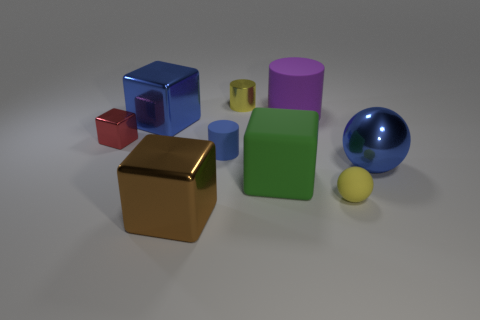Add 1 blue metal blocks. How many objects exist? 10 Subtract all cylinders. How many objects are left? 6 Add 5 yellow objects. How many yellow objects are left? 7 Add 2 large red balls. How many large red balls exist? 2 Subtract 1 yellow cylinders. How many objects are left? 8 Subtract all blue balls. Subtract all small spheres. How many objects are left? 7 